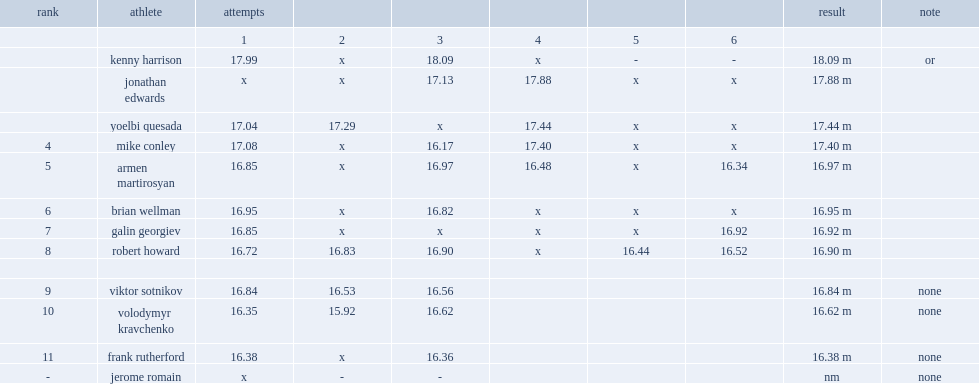In the 1996 summer olympics, what was the result did jonathan edwards make a jump of? 17.13. 